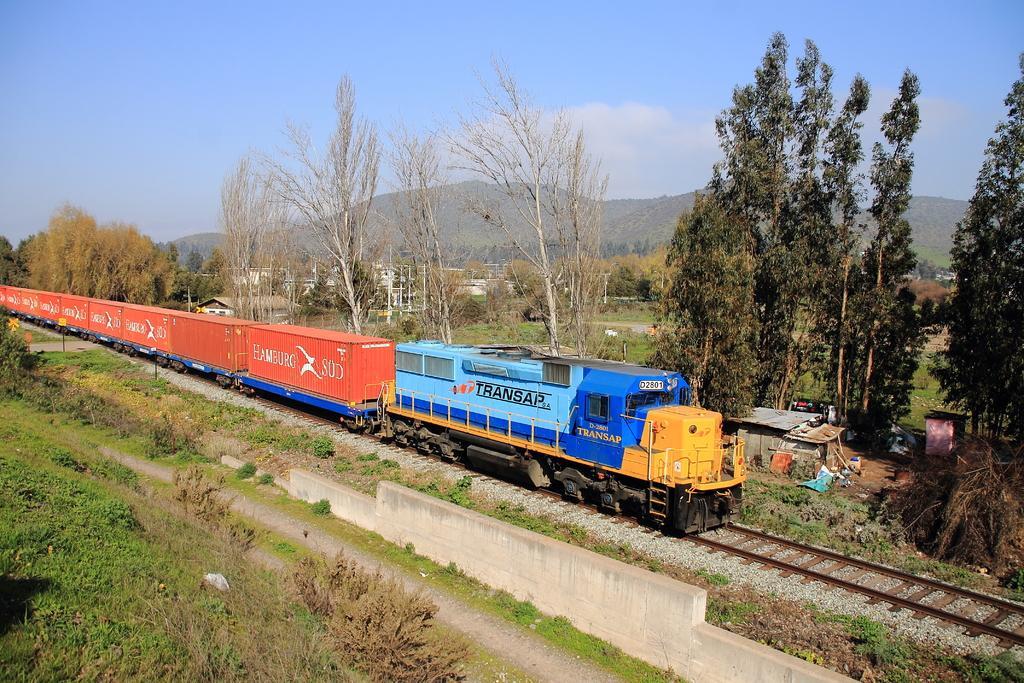How would you summarize this image in a sentence or two? There is a goods train on a railway track. On the sides there are plants. In the back there are trees, hills and sky. On the train something is written. 